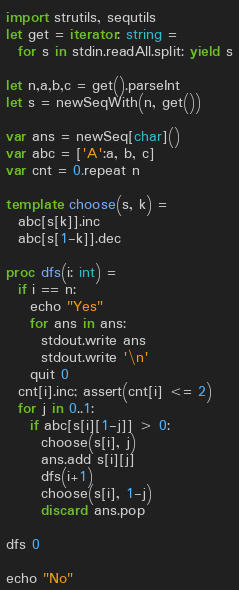Convert code to text. <code><loc_0><loc_0><loc_500><loc_500><_Nim_>import strutils, sequtils
let get = iterator: string =
  for s in stdin.readAll.split: yield s

let n,a,b,c = get().parseInt
let s = newSeqWith(n, get())

var ans = newSeq[char]()
var abc = ['A':a, b, c]
var cnt = 0.repeat n

template choose(s, k) =
  abc[s[k]].inc
  abc[s[1-k]].dec

proc dfs(i: int) =
  if i == n:
    echo "Yes"
    for ans in ans:
      stdout.write ans
      stdout.write '\n'
    quit 0
  cnt[i].inc; assert(cnt[i] <= 2)
  for j in 0..1:
    if abc[s[i][1-j]] > 0:
      choose(s[i], j)
      ans.add s[i][j]
      dfs(i+1)
      choose(s[i], 1-j)
      discard ans.pop

dfs 0

echo "No"
</code> 